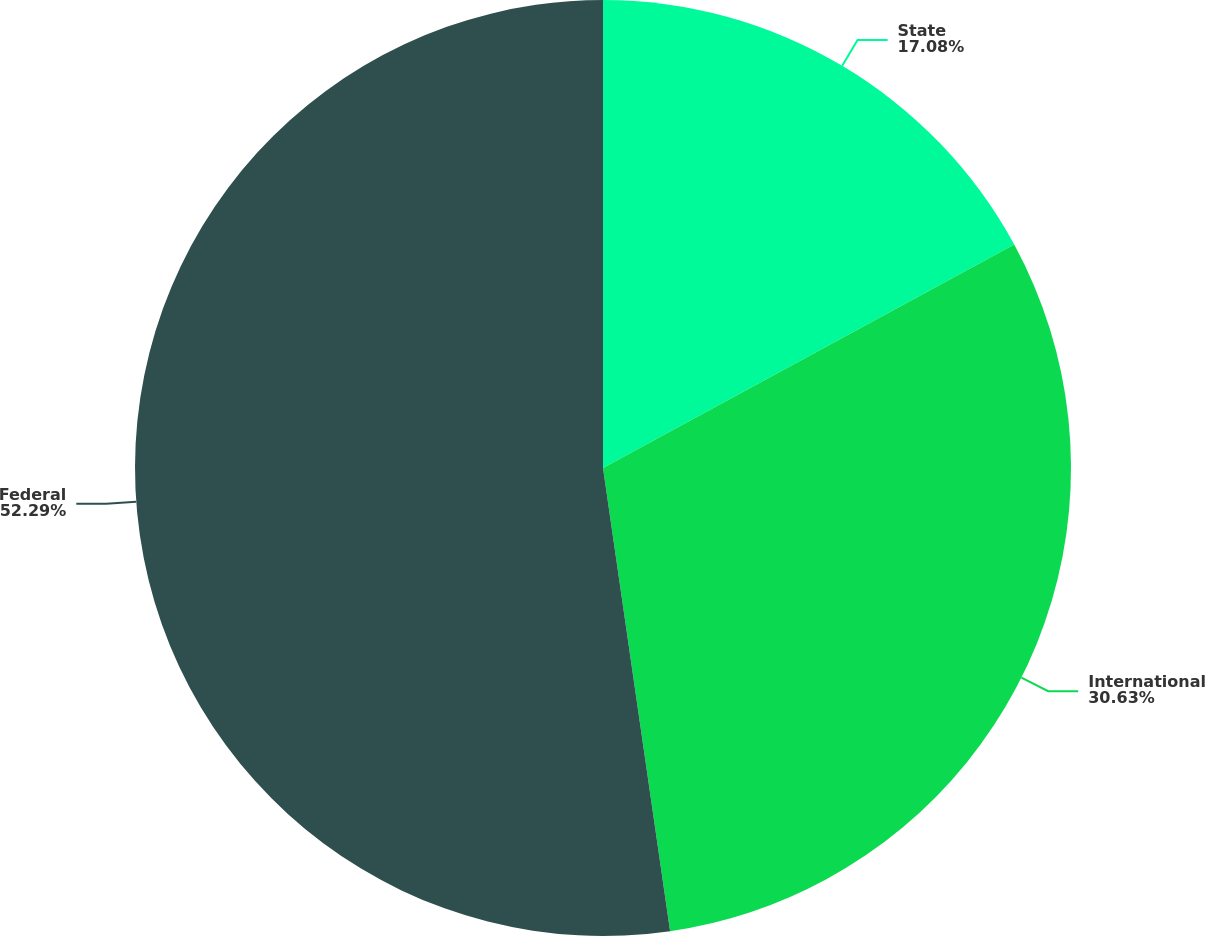<chart> <loc_0><loc_0><loc_500><loc_500><pie_chart><fcel>State<fcel>International<fcel>Federal<nl><fcel>17.08%<fcel>30.63%<fcel>52.29%<nl></chart> 